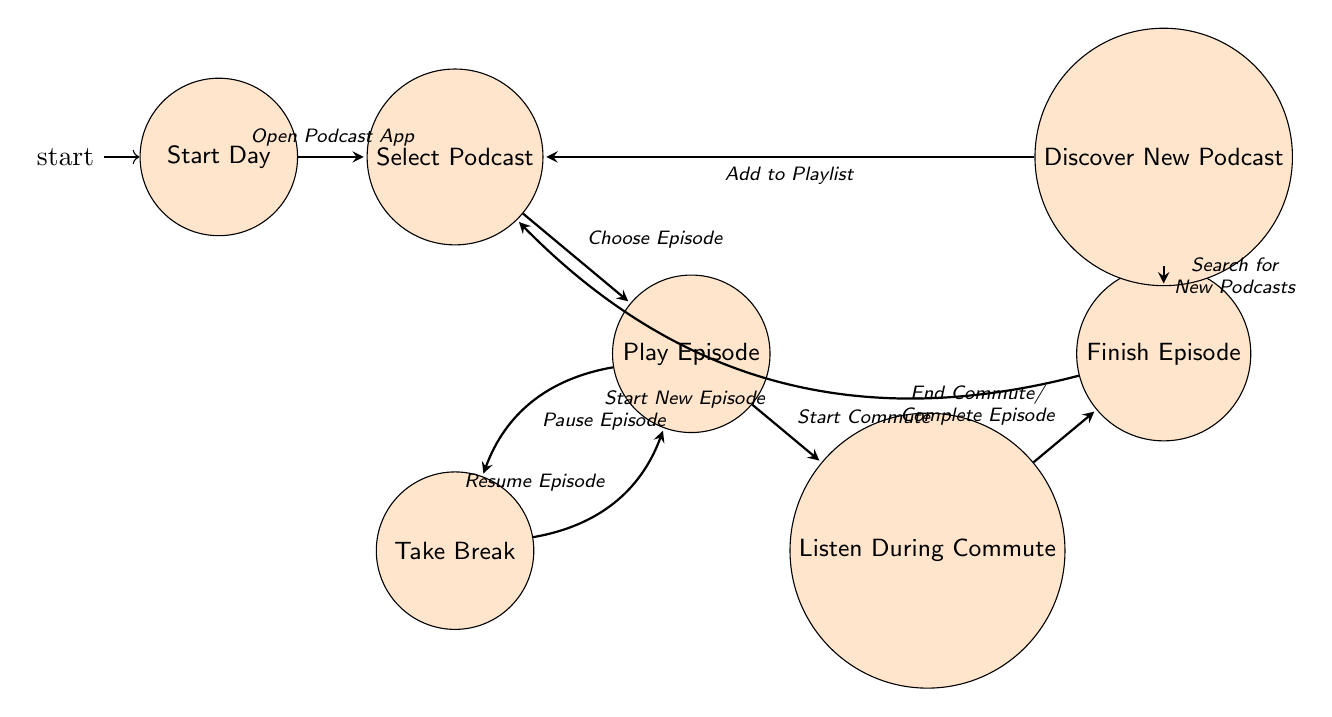What is the first state of the machine? The diagram begins at the "Start Day," which is the initial state of the podcast listening routine.
Answer: Start Day How many states are there in the diagram? By counting the distinct labeled circles representing different activities or states within the diagram, we confirm there are a total of seven states.
Answer: 7 What triggers the transition from "Select Podcast" to "Play Episode"? The passage from the "Select Podcast" state to "Play Episode" occurs when the user "Chooses Episode."
Answer: Choose Episode From which state can "Discover New Podcast" be reached? "Discover New Podcast" can be reached from "Finish Episode" when the trigger "Search for New Podcasts" is activated.
Answer: Finish Episode What is the last state before returning to "Select Podcast"? The final state before cycling back to "Select Podcast" is "Finish Episode," which follows either the completion of the episode or ending of the commute.
Answer: Finish Episode How many transitions are there leading out of the "Play Episode" state? Upon reviewing the transitions that connect from the "Play Episode" state, we find there are three paths leading to "Take Break," "Listen During Commute," and the return back after completion of the episode.
Answer: 3 What is the trigger that leads from "Take Break" back to "Play Episode"? The transition to return to "Play Episode" after a break is prompted by the trigger "Resume Episode."
Answer: Resume Episode Can you list two possible transitions from the "Finish Episode" state? The two possible transitions from "Finish Episode" are: one to "Select Podcast" triggered by "Start New Episode," and another to "Discover New Podcast" triggered by "Search for New Podcasts."
Answer: Select Podcast, Discover New Podcast 